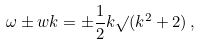Convert formula to latex. <formula><loc_0><loc_0><loc_500><loc_500>\omega \pm w k = \pm \frac { 1 } { 2 } k \surd ( k ^ { 2 } + 2 ) \, ,</formula> 